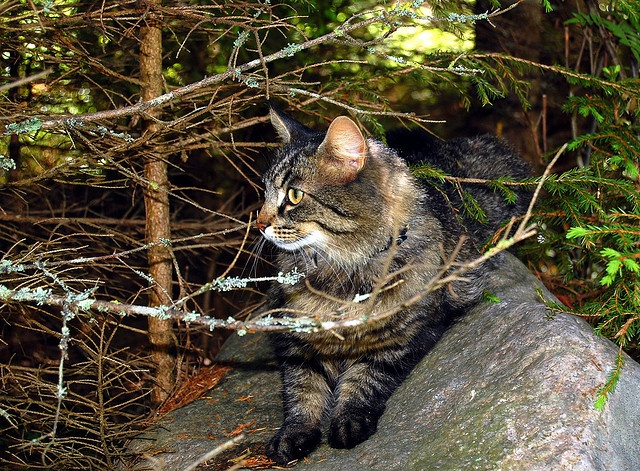Describe the objects in this image and their specific colors. I can see a cat in green, black, gray, and tan tones in this image. 